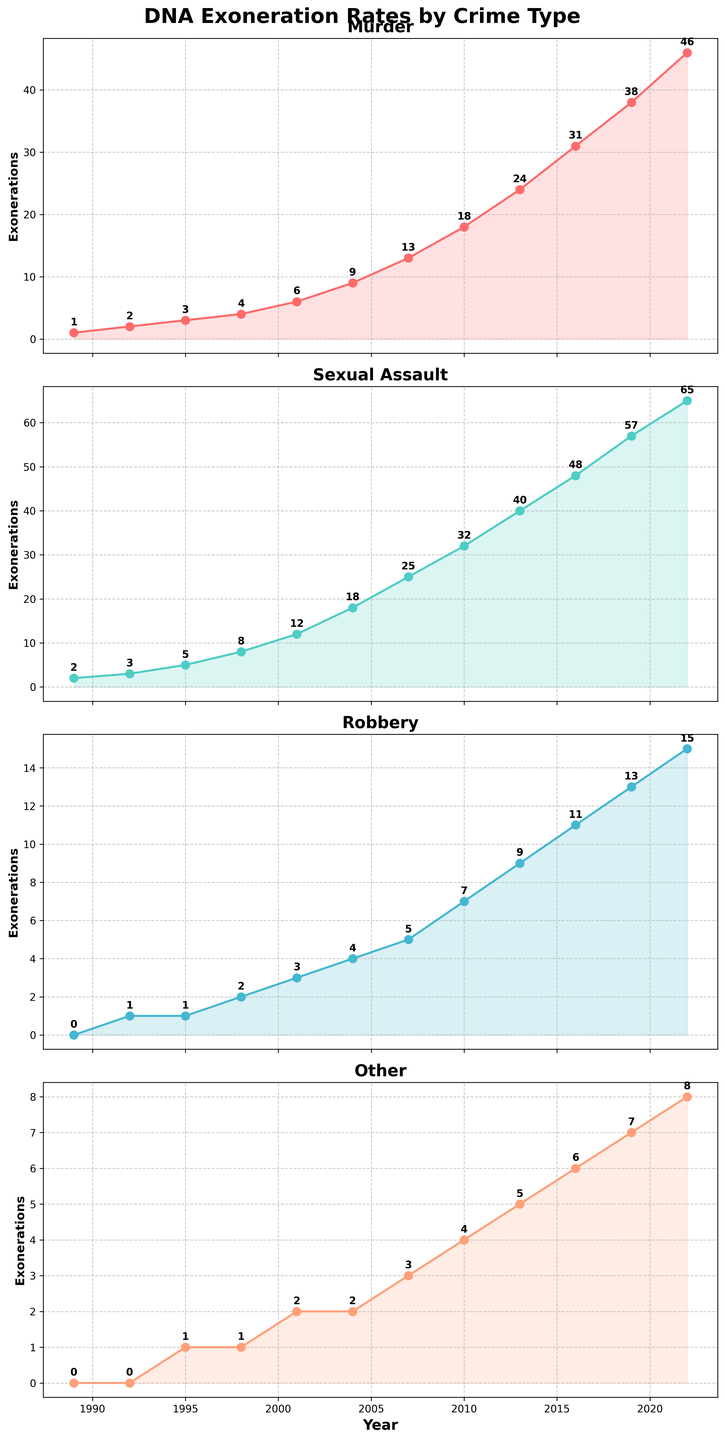What's the total number of DNA exonerations for Murder by 2022? Add the exonerations for Murder across all years: 1+2+3+4+6+9+13+18+24+31+38+46. Summing these values gives 195.
Answer: 195 Which crime type had the highest number of exonerations in 2016? Look at the 2016 data points for all crimes: Murder (31), Sexual Assault (48), Robbery (11), and Other (6). Sexual Assault has the highest value.
Answer: Sexual Assault How does the number of exonerations for Robbery in 2007 compare to those for Other in the same year? Refer to 2007 values: Robbery had 5 exonerations, while Other had 3. Thus, Robbery had more exonerations than Other in 2007.
Answer: Robbery has more What's the average number of exonerations for Sexual Assault over the entire period shown? Sum the exonerations for Sexual Assault: 2+3+5+8+12+18+25+32+40+48+57+65 = 315. Divide by the number of years (12) to get the average, 315/12 ≈ 26.25.
Answer: 26.25 Compare the growth rate of exonerations between Murder and Sexual Assault from 2001 to 2010. Which one increased more? Calculate the increase for Murder from 2001 (6) to 2010 (18) which is 18-6 = 12. For Sexual Assault from 2001 (12) to 2010 (32), the increase is 32-12 = 20. Thus, Sexual Assault increased by a higher number.
Answer: Sexual Assault increased more In what year did the exonerations for Other first surpass 5? Check the Other category's data across the years. The first year where exonerations for Other exceed 5 is 2013, with 6 exonerations.
Answer: 2013 Which crime type has shown the steadiest increase in the number of exonerations over time? Observing the trend lines for all crime types, Murder shows a consistent upward trend without large fluctuations compared to others.
Answer: Murder Between 2010 and 2019, which crime type saw the least increase in exonerations? Calculate the increases: Murder (38-18 = 20), Sexual Assault (57-32 = 25), Robbery (13-7 = 6), Other (7-4 = 3). Other has the smallest increase.
Answer: Other What's the difference in the number of exonerations for Murder between 2016 and 2022? Subtract the 2016 value for Murder (31) from the 2022 value (46): 46 - 31 = 15.
Answer: 15 